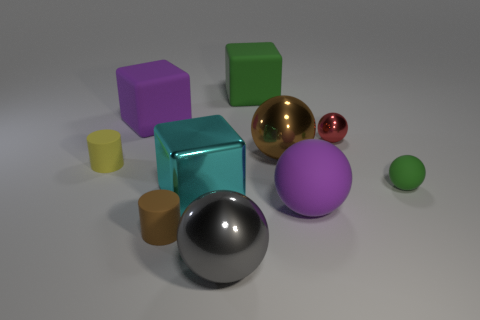How many objects are tiny brown cylinders or large rubber blocks on the left side of the brown rubber object?
Offer a very short reply. 2. What is the material of the sphere that is on the left side of the big object behind the large purple object that is behind the small yellow cylinder?
Provide a short and direct response. Metal. The other green object that is the same material as the small green thing is what size?
Your answer should be very brief. Large. What is the color of the small matte object right of the big sphere to the left of the brown metallic thing?
Offer a terse response. Green. What number of tiny green things have the same material as the small brown cylinder?
Provide a short and direct response. 1. How many rubber objects are either large cyan things or gray balls?
Provide a short and direct response. 0. What is the material of the gray object that is the same size as the purple ball?
Offer a very short reply. Metal. Is there a cube that has the same material as the small brown object?
Give a very brief answer. Yes. What is the shape of the big matte object that is on the left side of the shiny block behind the big purple object that is right of the tiny brown rubber cylinder?
Keep it short and to the point. Cube. Do the green ball and the block that is left of the cyan metallic thing have the same size?
Your answer should be compact. No. 